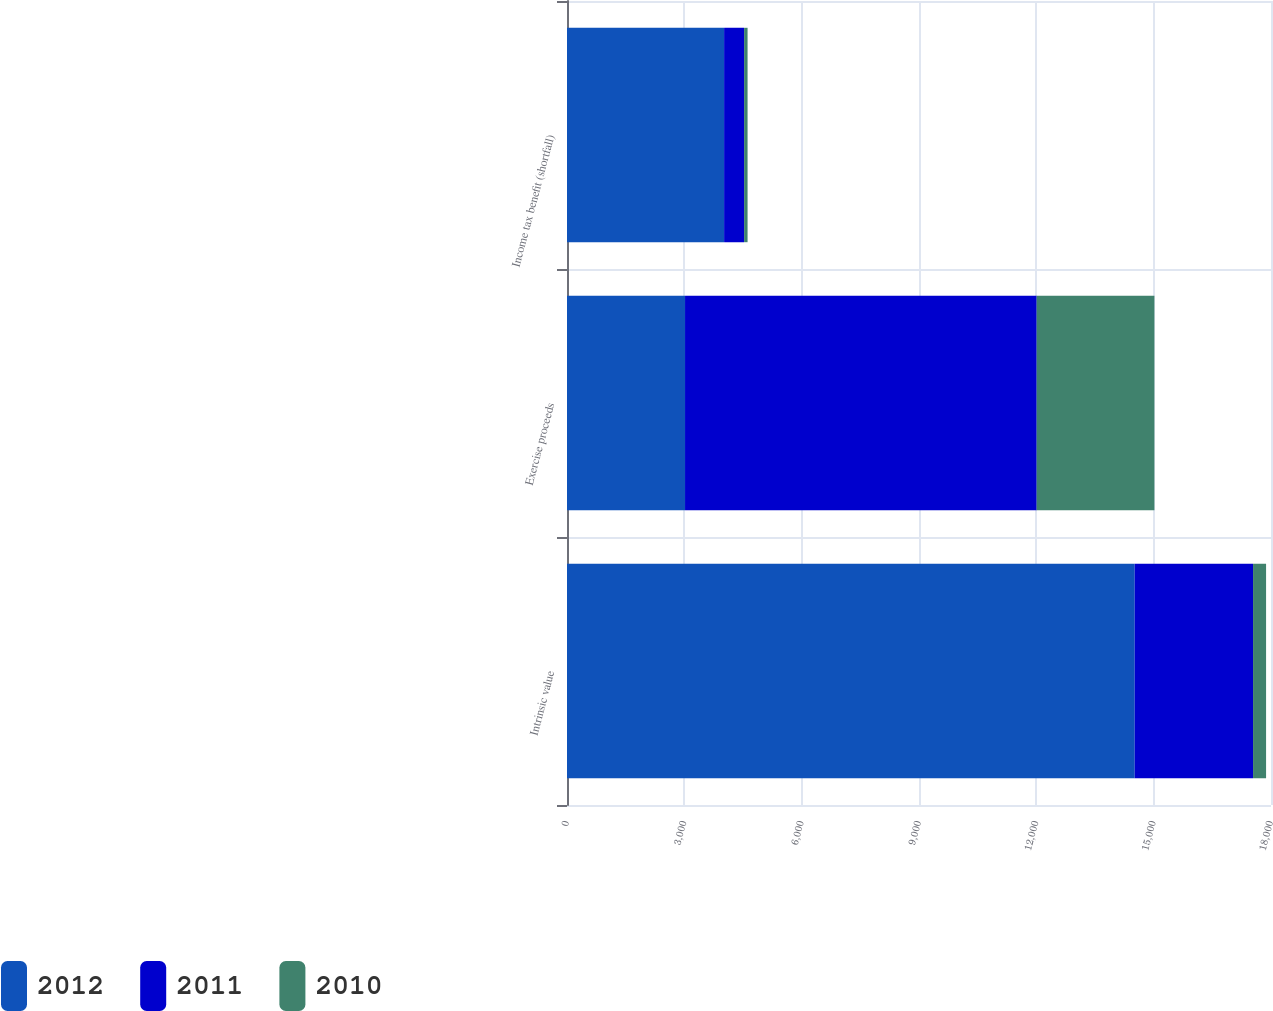Convert chart to OTSL. <chart><loc_0><loc_0><loc_500><loc_500><stacked_bar_chart><ecel><fcel>Intrinsic value<fcel>Exercise proceeds<fcel>Income tax benefit (shortfall)<nl><fcel>2012<fcel>14515<fcel>3018<fcel>4017<nl><fcel>2011<fcel>3026<fcel>8991<fcel>511<nl><fcel>2010<fcel>333<fcel>3010<fcel>89<nl></chart> 